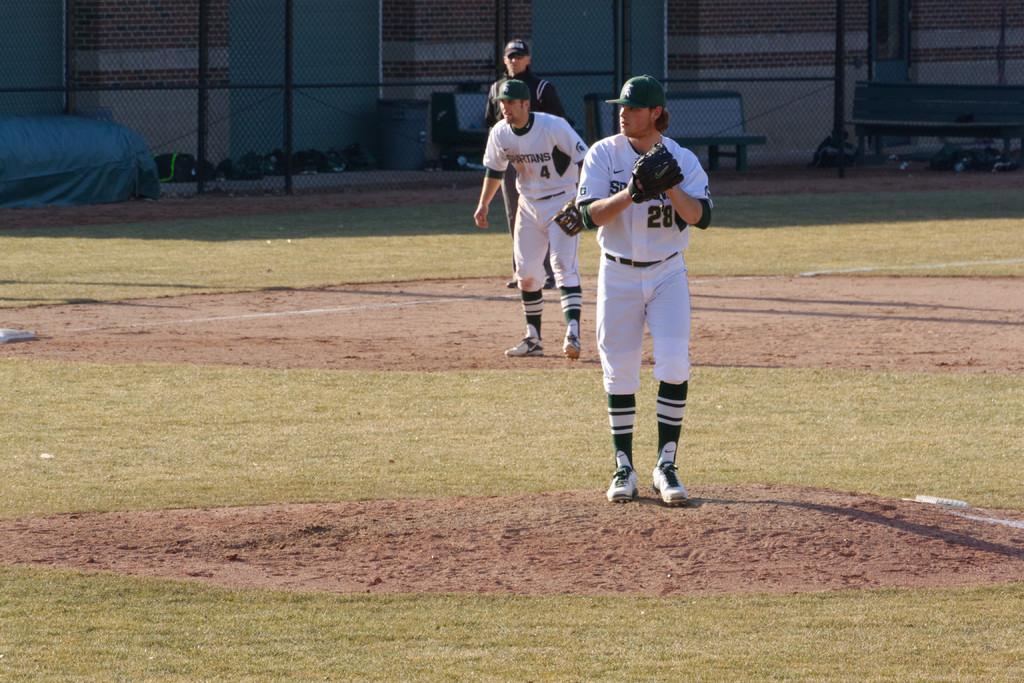What number is the pitcher wearing?
Provide a short and direct response. 28. 